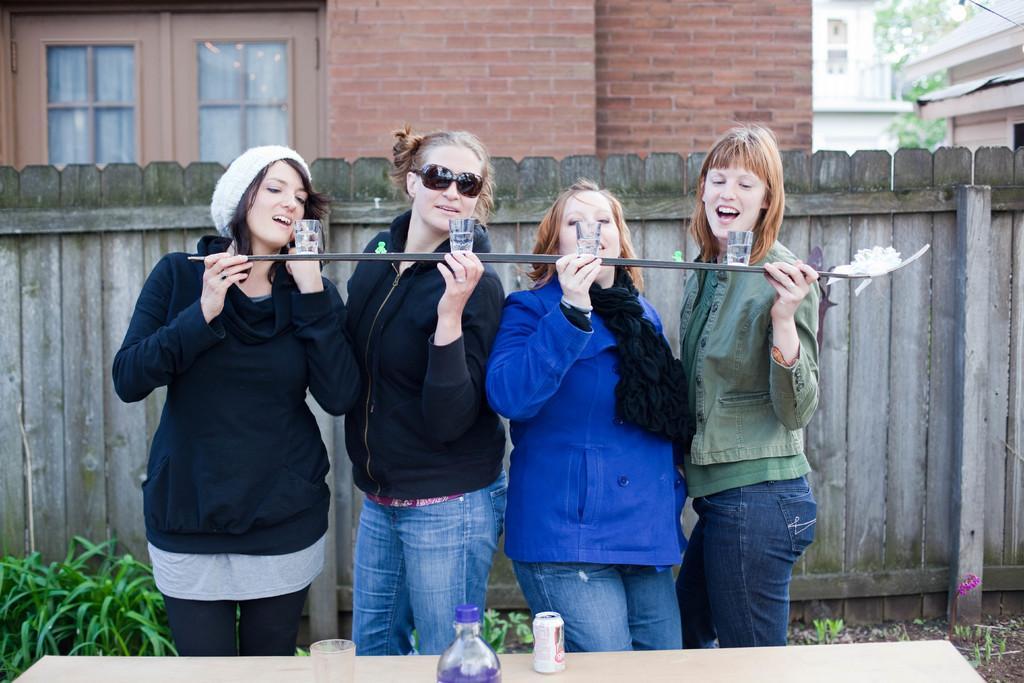Describe this image in one or two sentences. Here I can see four women wearing jackets, standing and holding a stick kind of object in their hands. On this stick there are four glasses with water. These women are looking at the glasses and it seems like they are speaking. At the bottom there is a table on which a glass, bottle and a coke-tin are placed. At the back of these people there are few plants and a fencing. In the background there are few buildings and trees. 